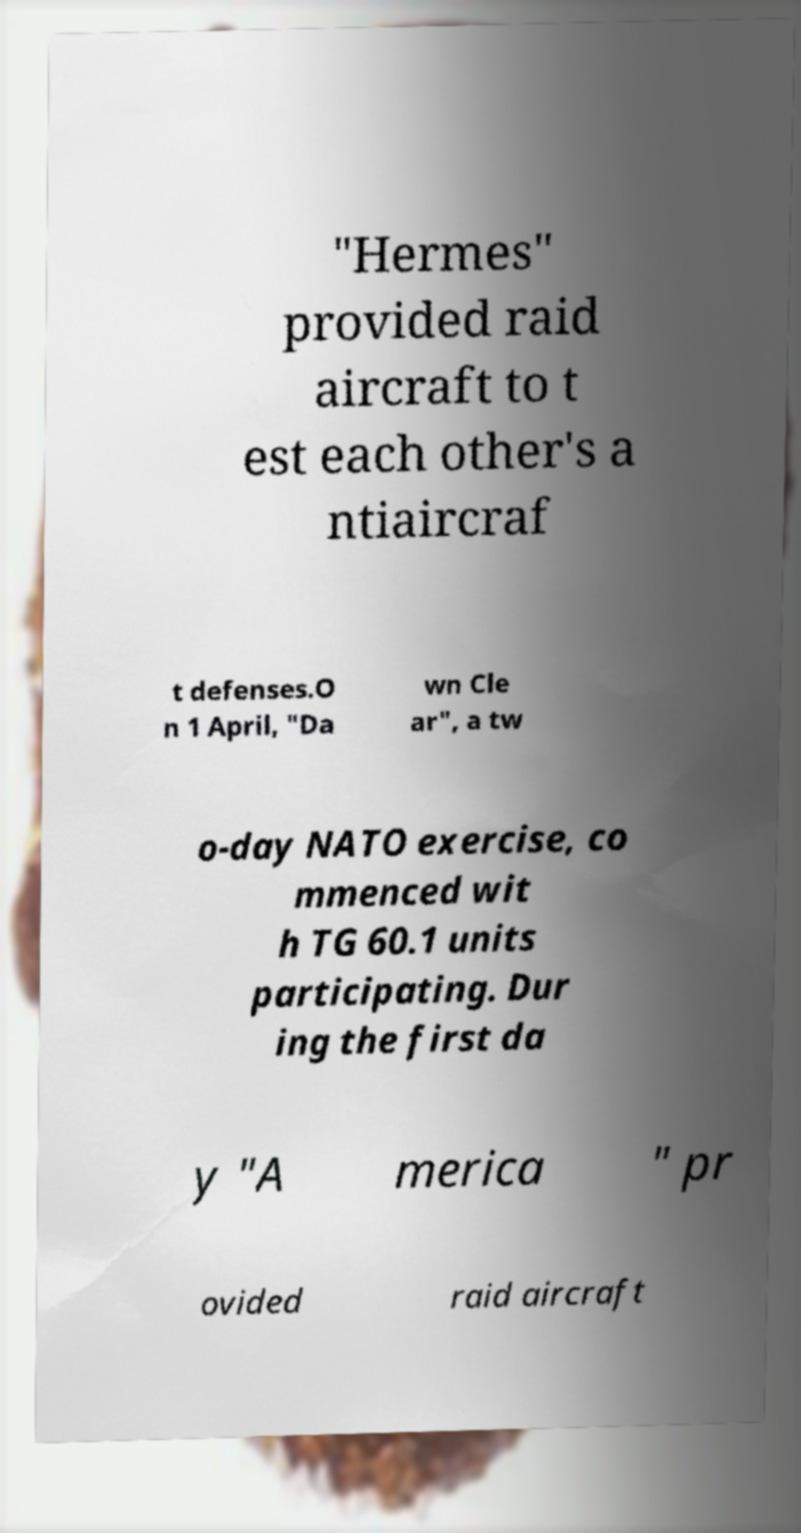Could you assist in decoding the text presented in this image and type it out clearly? "Hermes" provided raid aircraft to t est each other's a ntiaircraf t defenses.O n 1 April, "Da wn Cle ar", a tw o-day NATO exercise, co mmenced wit h TG 60.1 units participating. Dur ing the first da y "A merica " pr ovided raid aircraft 